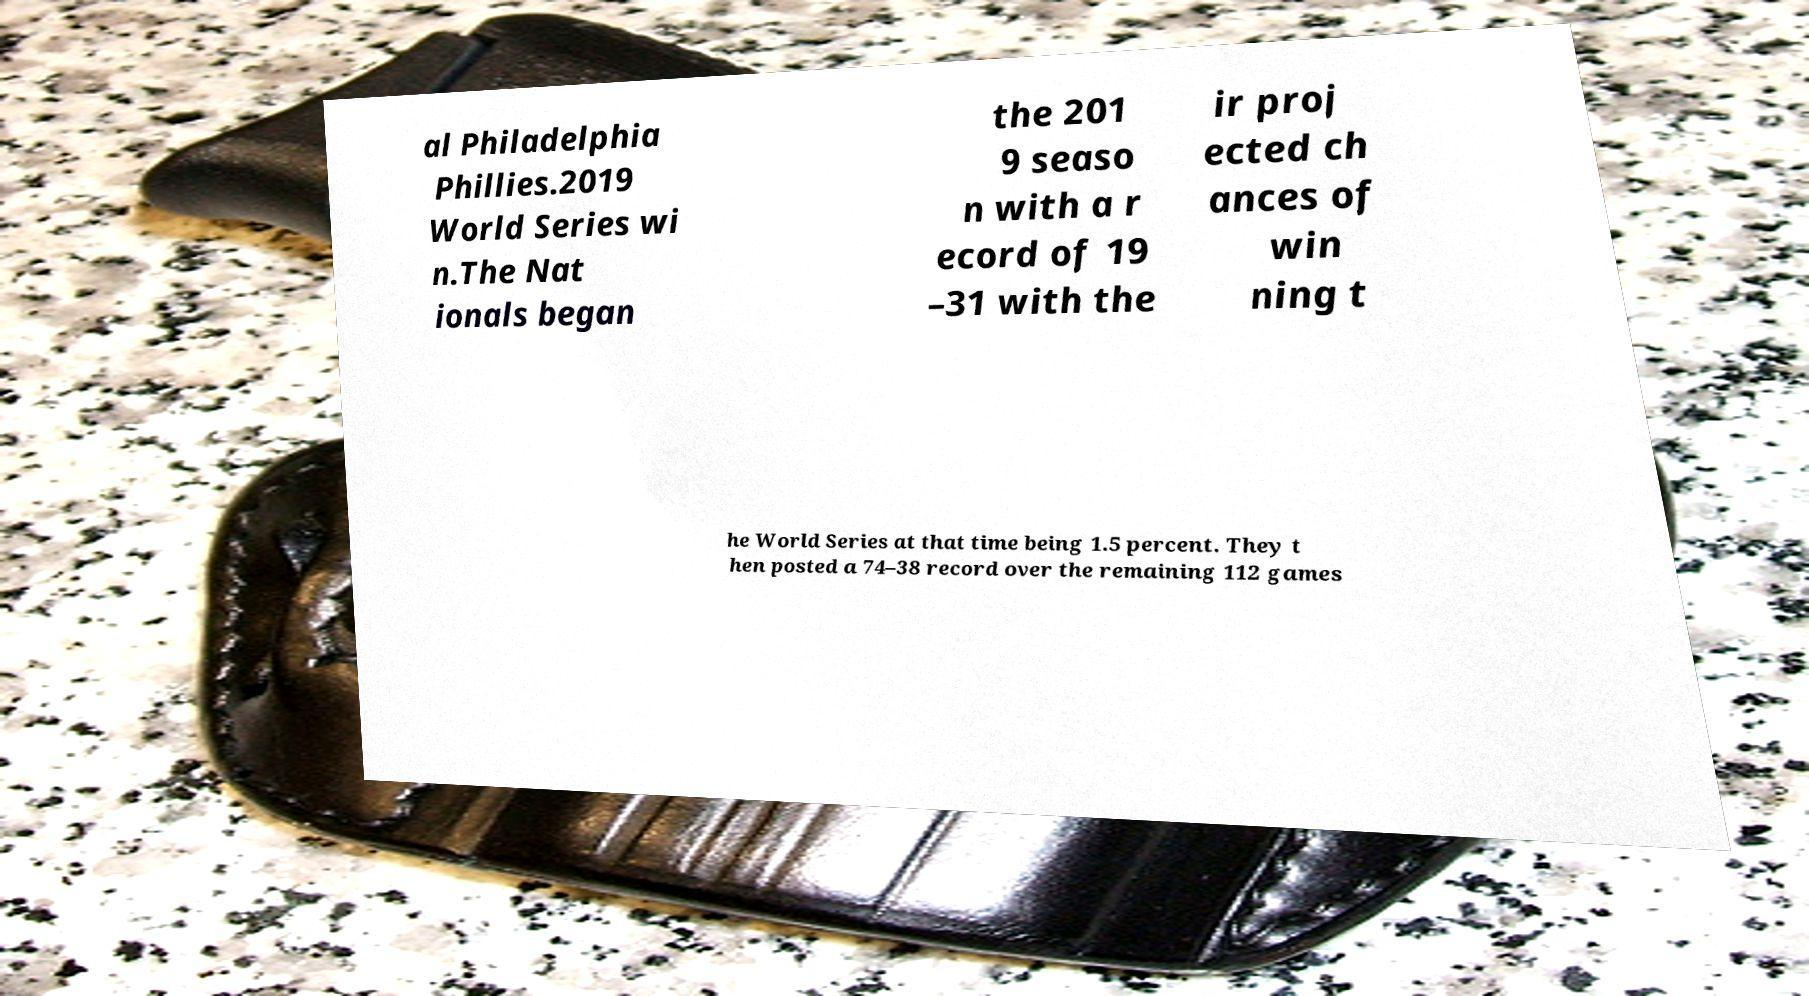Can you read and provide the text displayed in the image?This photo seems to have some interesting text. Can you extract and type it out for me? al Philadelphia Phillies.2019 World Series wi n.The Nat ionals began the 201 9 seaso n with a r ecord of 19 –31 with the ir proj ected ch ances of win ning t he World Series at that time being 1.5 percent. They t hen posted a 74–38 record over the remaining 112 games 